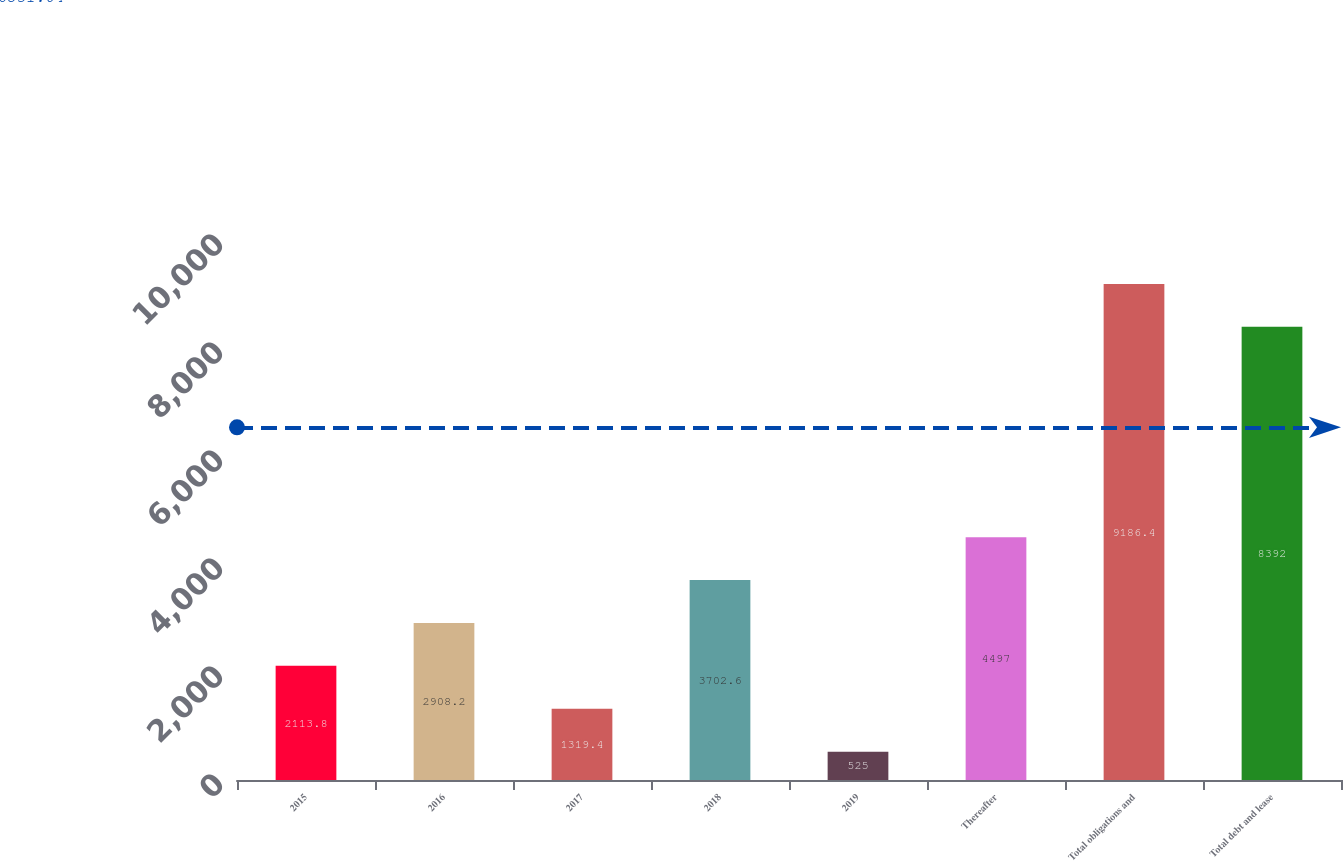Convert chart. <chart><loc_0><loc_0><loc_500><loc_500><bar_chart><fcel>2015<fcel>2016<fcel>2017<fcel>2018<fcel>2019<fcel>Thereafter<fcel>Total obligations and<fcel>Total debt and lease<nl><fcel>2113.8<fcel>2908.2<fcel>1319.4<fcel>3702.6<fcel>525<fcel>4497<fcel>9186.4<fcel>8392<nl></chart> 